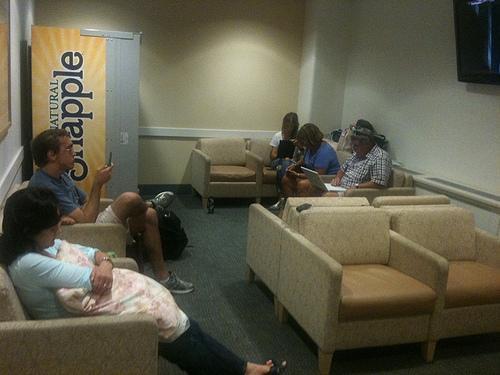How many people are wearing pants?
Give a very brief answer. 2. 